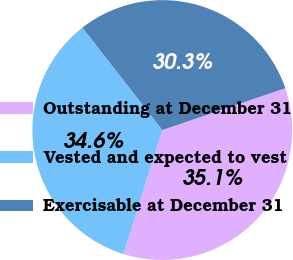<chart> <loc_0><loc_0><loc_500><loc_500><pie_chart><fcel>Outstanding at December 31<fcel>Vested and expected to vest<fcel>Exercisable at December 31<nl><fcel>35.06%<fcel>34.62%<fcel>30.32%<nl></chart> 